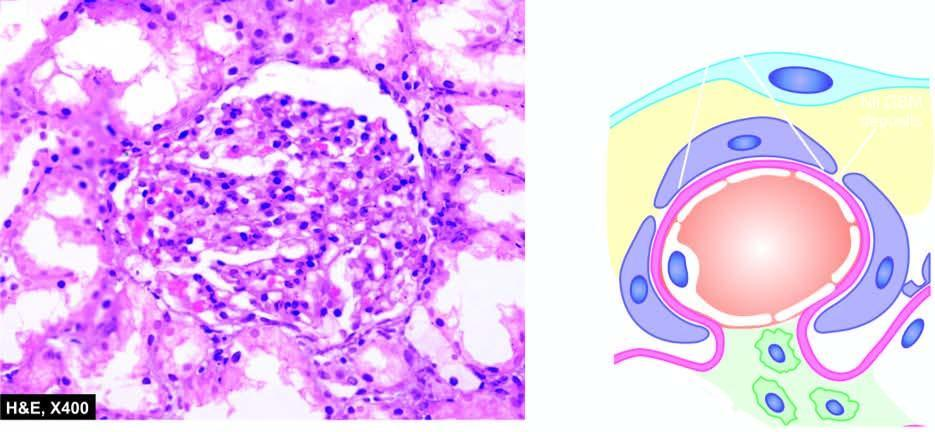s the gbm normal?
Answer the question using a single word or phrase. Yes 